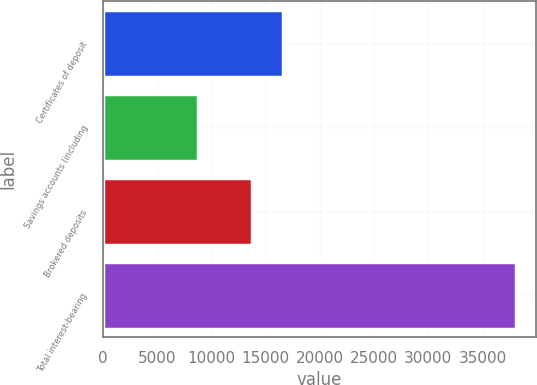<chart> <loc_0><loc_0><loc_500><loc_500><bar_chart><fcel>Certificates of deposit<fcel>Savings accounts (including<fcel>Brokered deposits<fcel>Total interest-bearing<nl><fcel>16643.9<fcel>8781<fcel>13716<fcel>38060<nl></chart> 